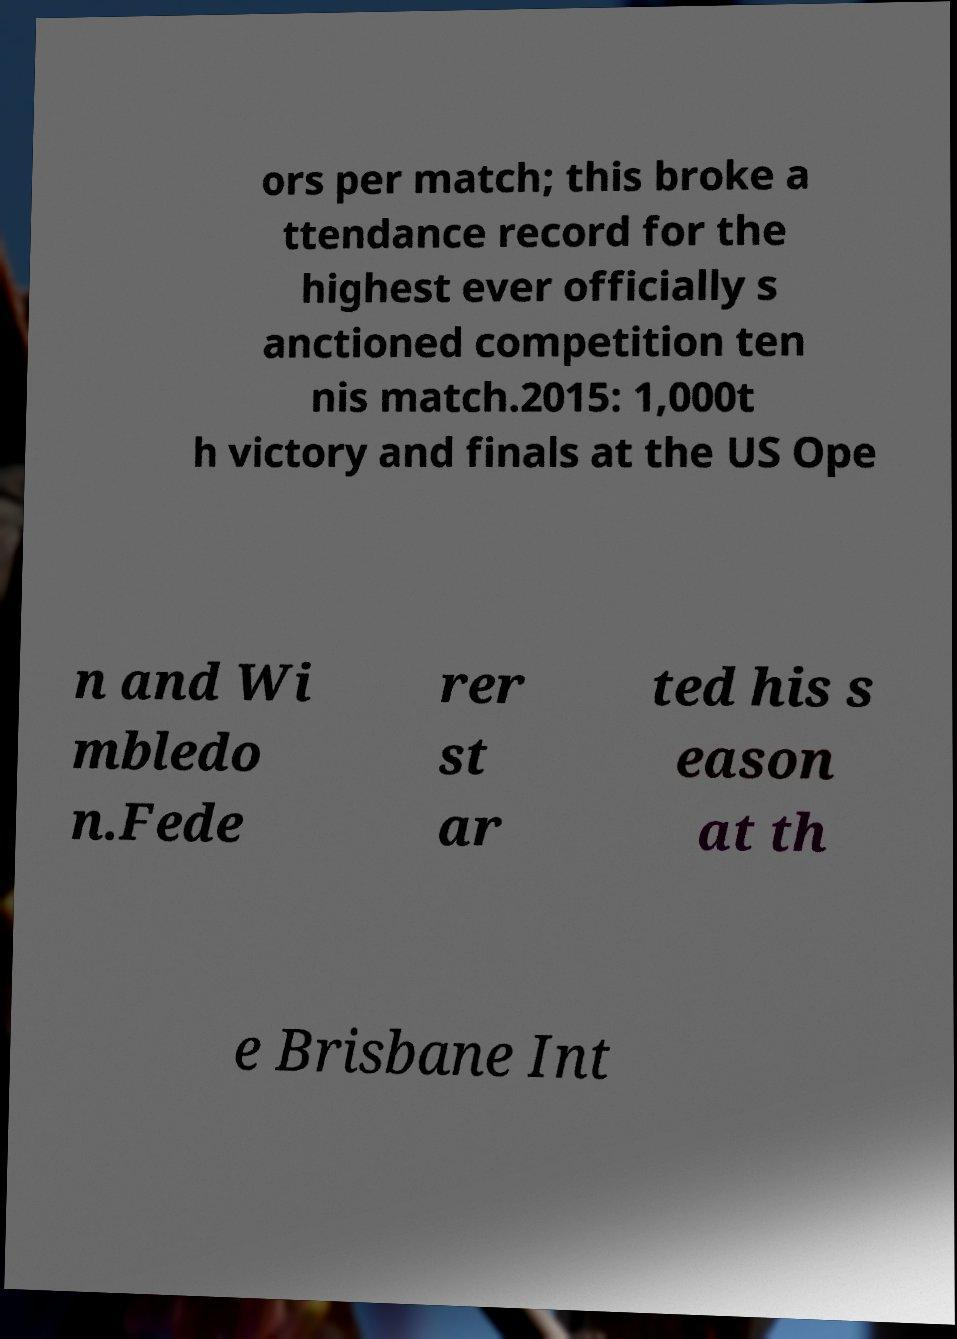For documentation purposes, I need the text within this image transcribed. Could you provide that? ors per match; this broke a ttendance record for the highest ever officially s anctioned competition ten nis match.2015: 1,000t h victory and finals at the US Ope n and Wi mbledo n.Fede rer st ar ted his s eason at th e Brisbane Int 